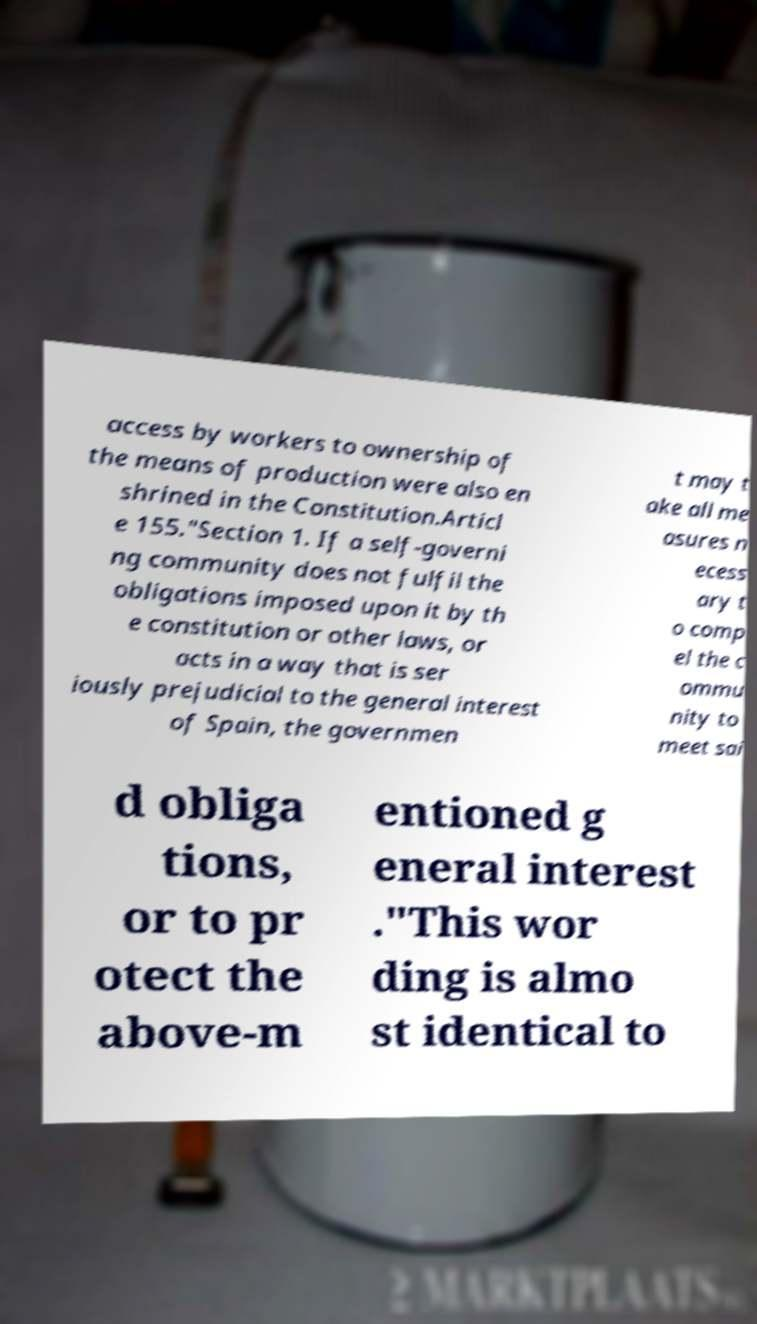Please read and relay the text visible in this image. What does it say? access by workers to ownership of the means of production were also en shrined in the Constitution.Articl e 155."Section 1. If a self-governi ng community does not fulfil the obligations imposed upon it by th e constitution or other laws, or acts in a way that is ser iously prejudicial to the general interest of Spain, the governmen t may t ake all me asures n ecess ary t o comp el the c ommu nity to meet sai d obliga tions, or to pr otect the above-m entioned g eneral interest ."This wor ding is almo st identical to 